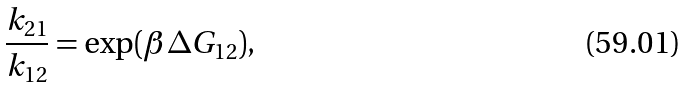Convert formula to latex. <formula><loc_0><loc_0><loc_500><loc_500>\frac { k _ { 2 1 } } { k _ { 1 2 } } = \exp ( \beta \Delta G _ { 1 2 } ) ,</formula> 